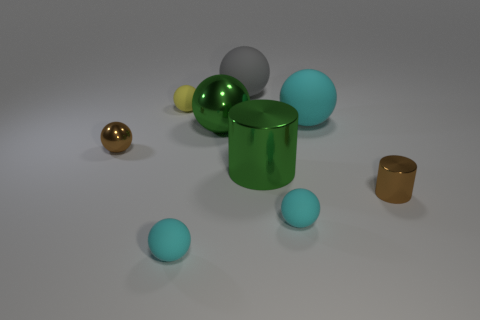Subtract all gray rubber spheres. How many spheres are left? 6 Subtract all green balls. How many balls are left? 6 Subtract all spheres. How many objects are left? 2 Add 8 large gray matte objects. How many large gray matte objects are left? 9 Add 4 big rubber spheres. How many big rubber spheres exist? 6 Subtract 1 brown balls. How many objects are left? 8 Subtract 2 cylinders. How many cylinders are left? 0 Subtract all green spheres. Subtract all yellow cylinders. How many spheres are left? 6 Subtract all yellow cylinders. How many gray balls are left? 1 Subtract all gray matte balls. Subtract all small yellow rubber objects. How many objects are left? 7 